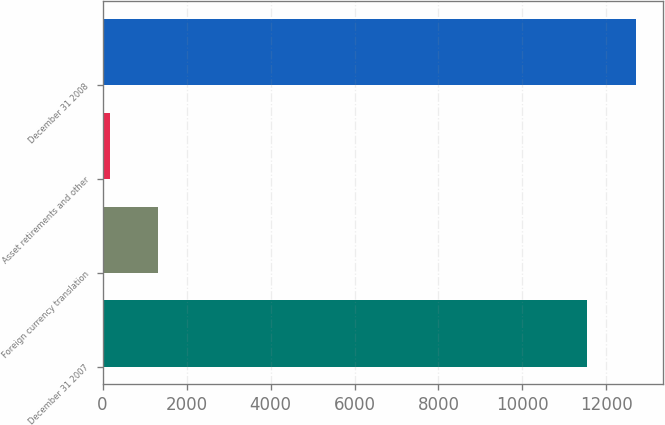Convert chart. <chart><loc_0><loc_0><loc_500><loc_500><bar_chart><fcel>December 31 2007<fcel>Foreign currency translation<fcel>Asset retirements and other<fcel>December 31 2008<nl><fcel>11549<fcel>1323.7<fcel>169<fcel>12703.7<nl></chart> 